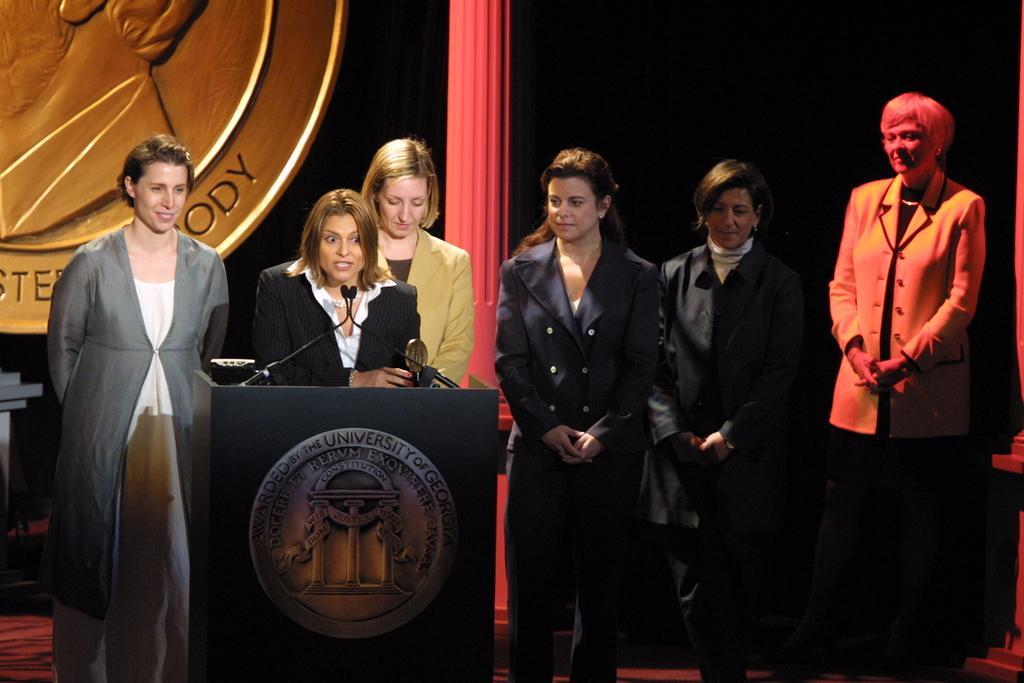Describe this image in one or two sentences. In this image there is a podium on which there are some lights, in front of the podium there are few people, behind him there is a pole, object, background is dark. 